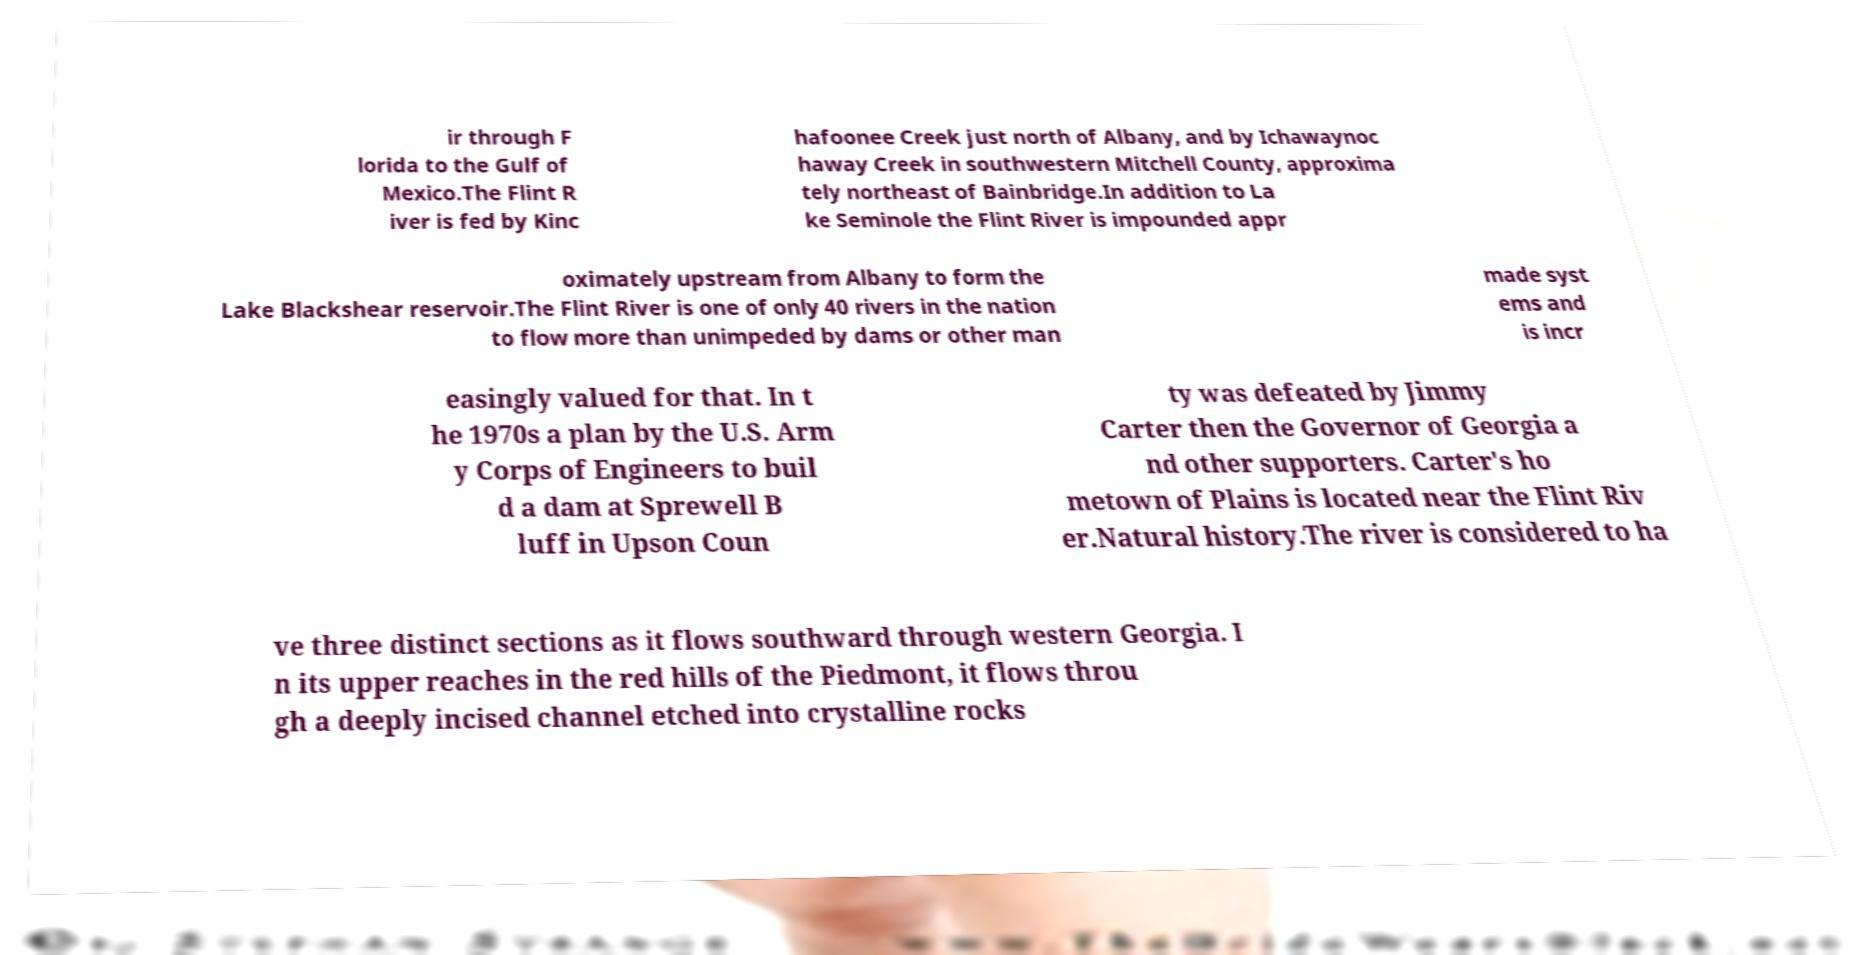Can you accurately transcribe the text from the provided image for me? ir through F lorida to the Gulf of Mexico.The Flint R iver is fed by Kinc hafoonee Creek just north of Albany, and by Ichawaynoc haway Creek in southwestern Mitchell County, approxima tely northeast of Bainbridge.In addition to La ke Seminole the Flint River is impounded appr oximately upstream from Albany to form the Lake Blackshear reservoir.The Flint River is one of only 40 rivers in the nation to flow more than unimpeded by dams or other man made syst ems and is incr easingly valued for that. In t he 1970s a plan by the U.S. Arm y Corps of Engineers to buil d a dam at Sprewell B luff in Upson Coun ty was defeated by Jimmy Carter then the Governor of Georgia a nd other supporters. Carter's ho metown of Plains is located near the Flint Riv er.Natural history.The river is considered to ha ve three distinct sections as it flows southward through western Georgia. I n its upper reaches in the red hills of the Piedmont, it flows throu gh a deeply incised channel etched into crystalline rocks 